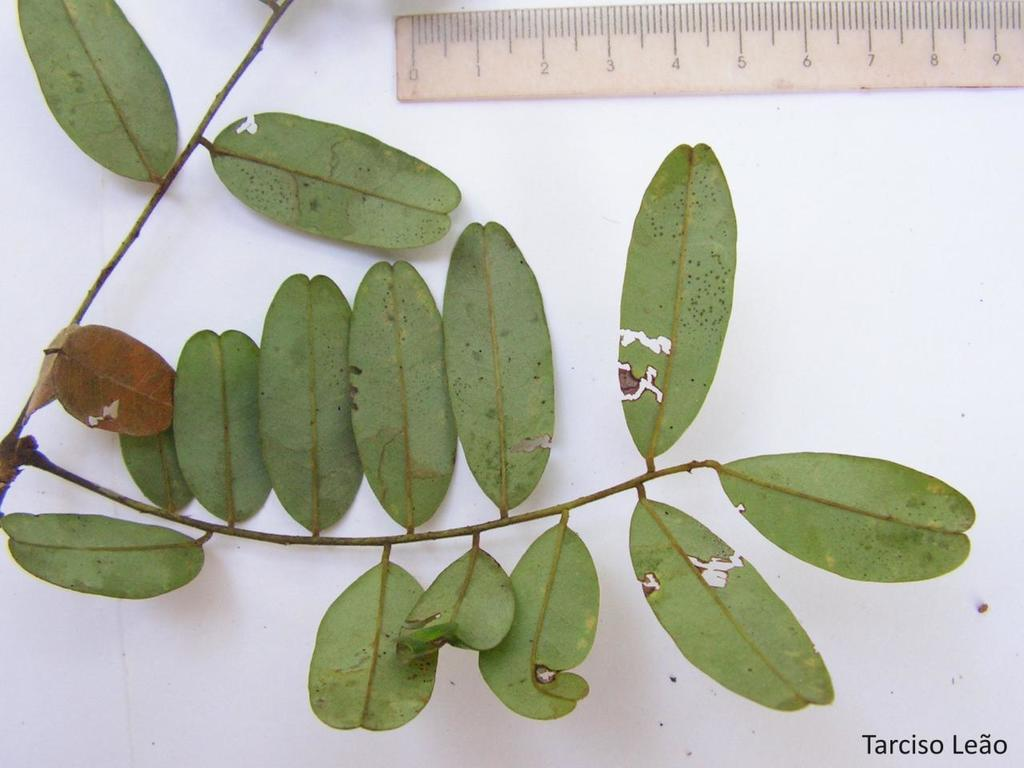What type of plant is visible in the image? There is a plant with leaves in the image. What object is present for measuring weight in the image? There is a scale in the image. What is the color of the surface on which the plant and scale are placed? The plant and scale are on a white surface. How many bears are visible in the image? There are no bears present in the image. What unit of measurement is being used on the scale in the image? The image does not specify the unit of measurement being used on the scale. 